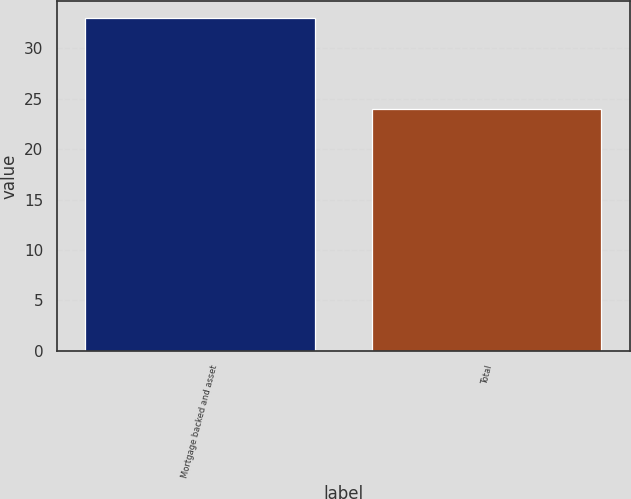Convert chart to OTSL. <chart><loc_0><loc_0><loc_500><loc_500><bar_chart><fcel>Mortgage backed and asset<fcel>Total<nl><fcel>33<fcel>24<nl></chart> 